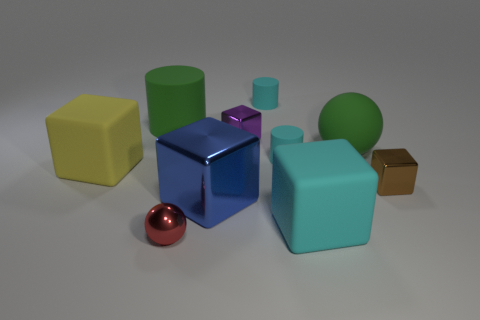How many other things are the same shape as the large metal object?
Provide a succinct answer. 4. Is the number of large yellow rubber blocks left of the large yellow rubber object the same as the number of green things in front of the red metal thing?
Provide a short and direct response. Yes. What is the material of the small purple cube?
Your response must be concise. Metal. What is the sphere in front of the big yellow object made of?
Offer a terse response. Metal. Is there anything else that has the same material as the cyan block?
Provide a succinct answer. Yes. Are there more small red metal balls to the right of the large blue thing than small cyan matte cylinders?
Ensure brevity in your answer.  No. Is there a brown object in front of the blue thing that is left of the big green matte object right of the large blue metallic thing?
Make the answer very short. No. There is a small brown shiny thing; are there any shiny things to the right of it?
Give a very brief answer. No. What number of big matte objects have the same color as the big cylinder?
Offer a very short reply. 1. What is the size of the purple thing that is the same material as the brown cube?
Offer a very short reply. Small. 